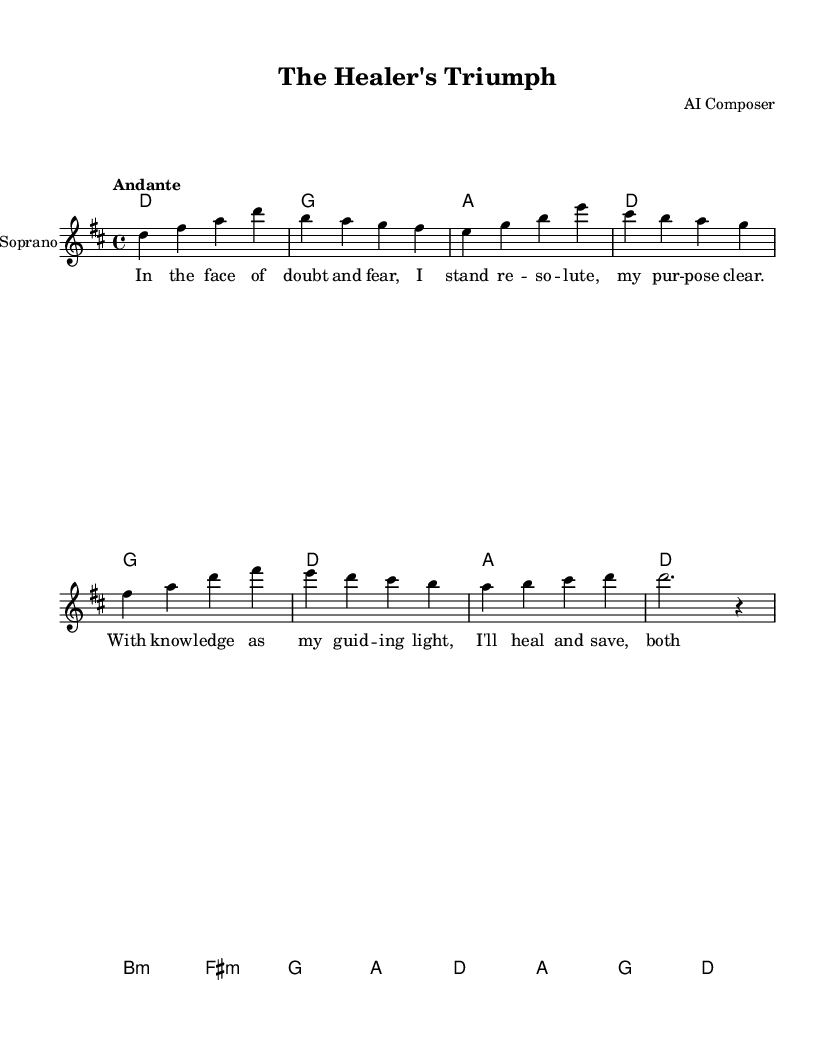What is the key signature of this music? The key signature indicates that there is an F sharp in the scale, characterizing D major. The music lacks any flat notes, confirming the major scale.
Answer: D major What is the time signature of this piece? The time signature is indicated by the 4/4 notation, meaning there are four beats in each measure and the quarter note gets one beat.
Answer: 4/4 What is the tempo of the piece? The tempo marking at the beginning says "Andante," which signifies a moderately slow tempo, generally around 76-108 beats per minute.
Answer: Andante How many measures are there in the soprano line? The soprano line consists of eight measures, each separated by vertical bars, as indicated by the notation layout.
Answer: Eight What is the main theme narrated in the lyrics? The lyrics express determination and resolve in the face of challenges, illustrating the protagonist's commitment to healing and saving lives.
Answer: Healing determination Which instrument is featured in the score? The score specifically names the instrument in the context of the new staff, which is identified as "Soprano."
Answer: Soprano 